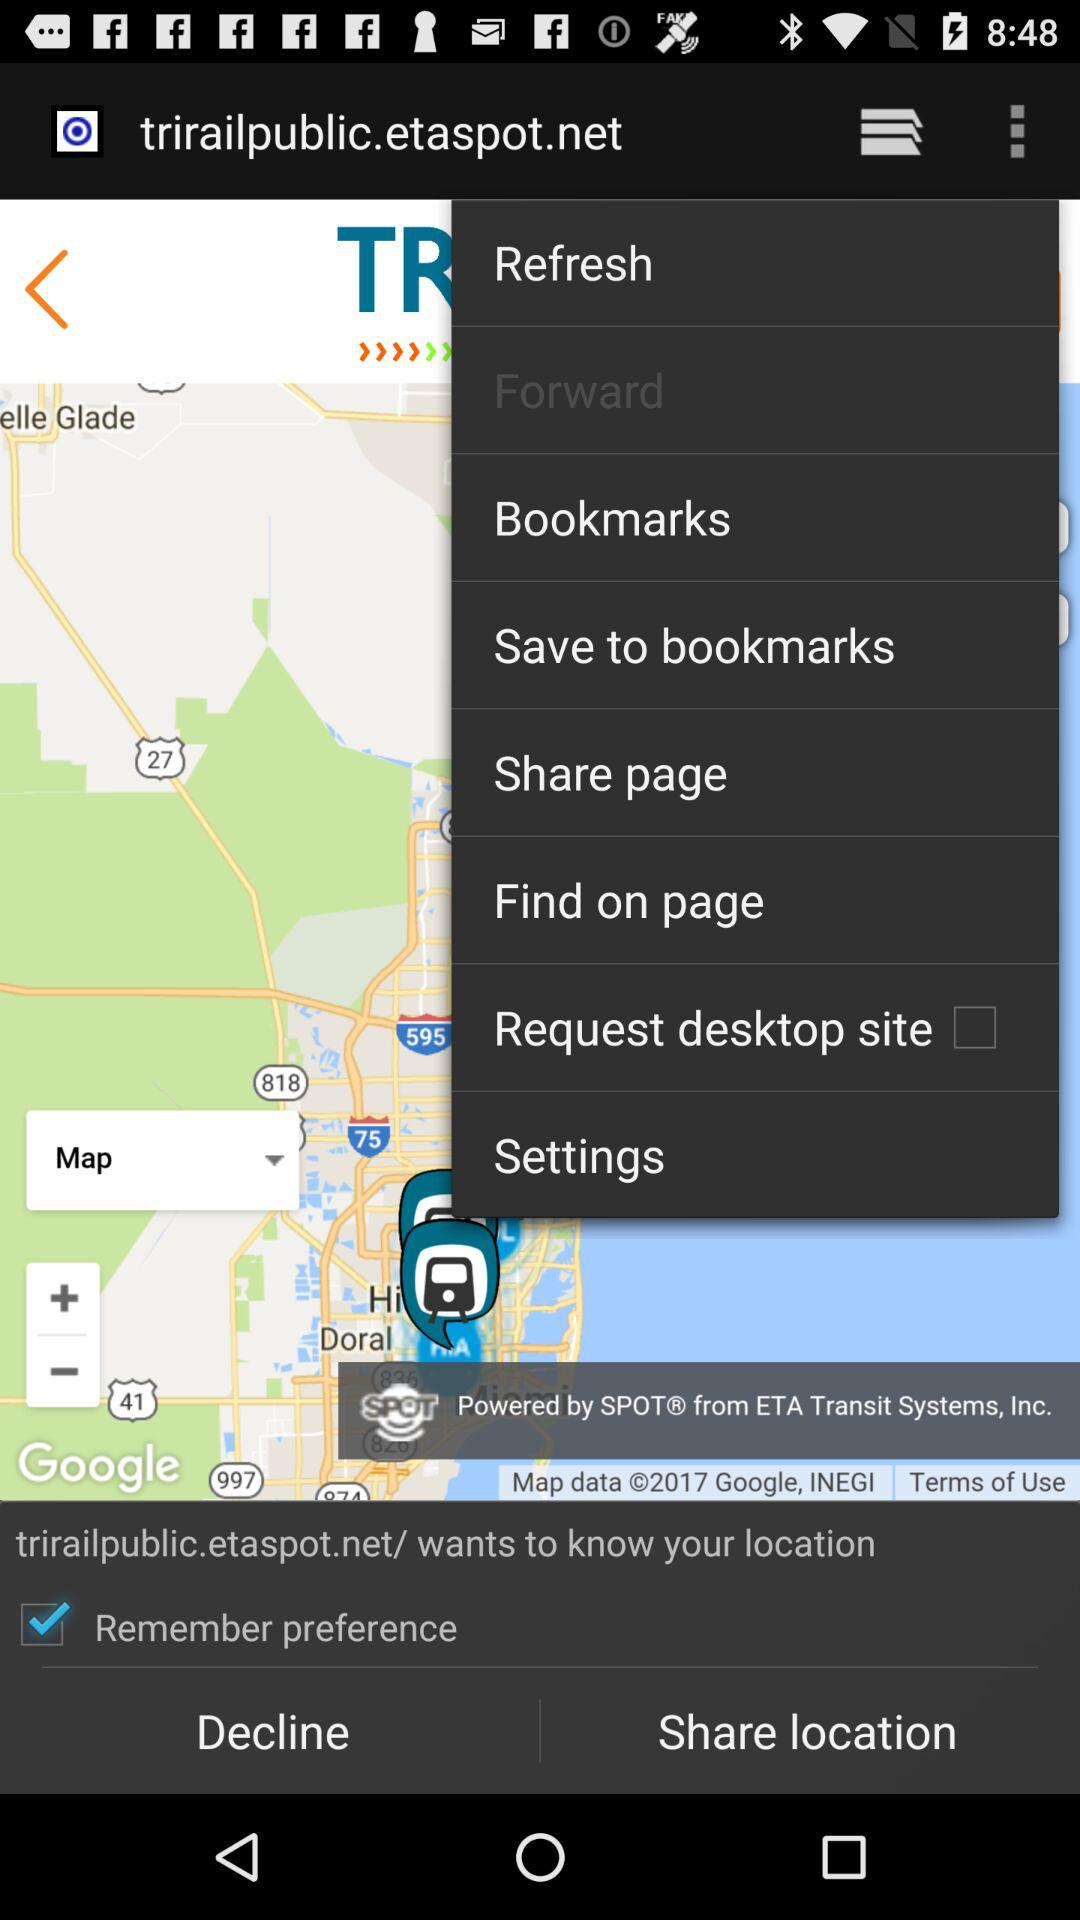What is the status of "Remember preference"? The status is "off". 